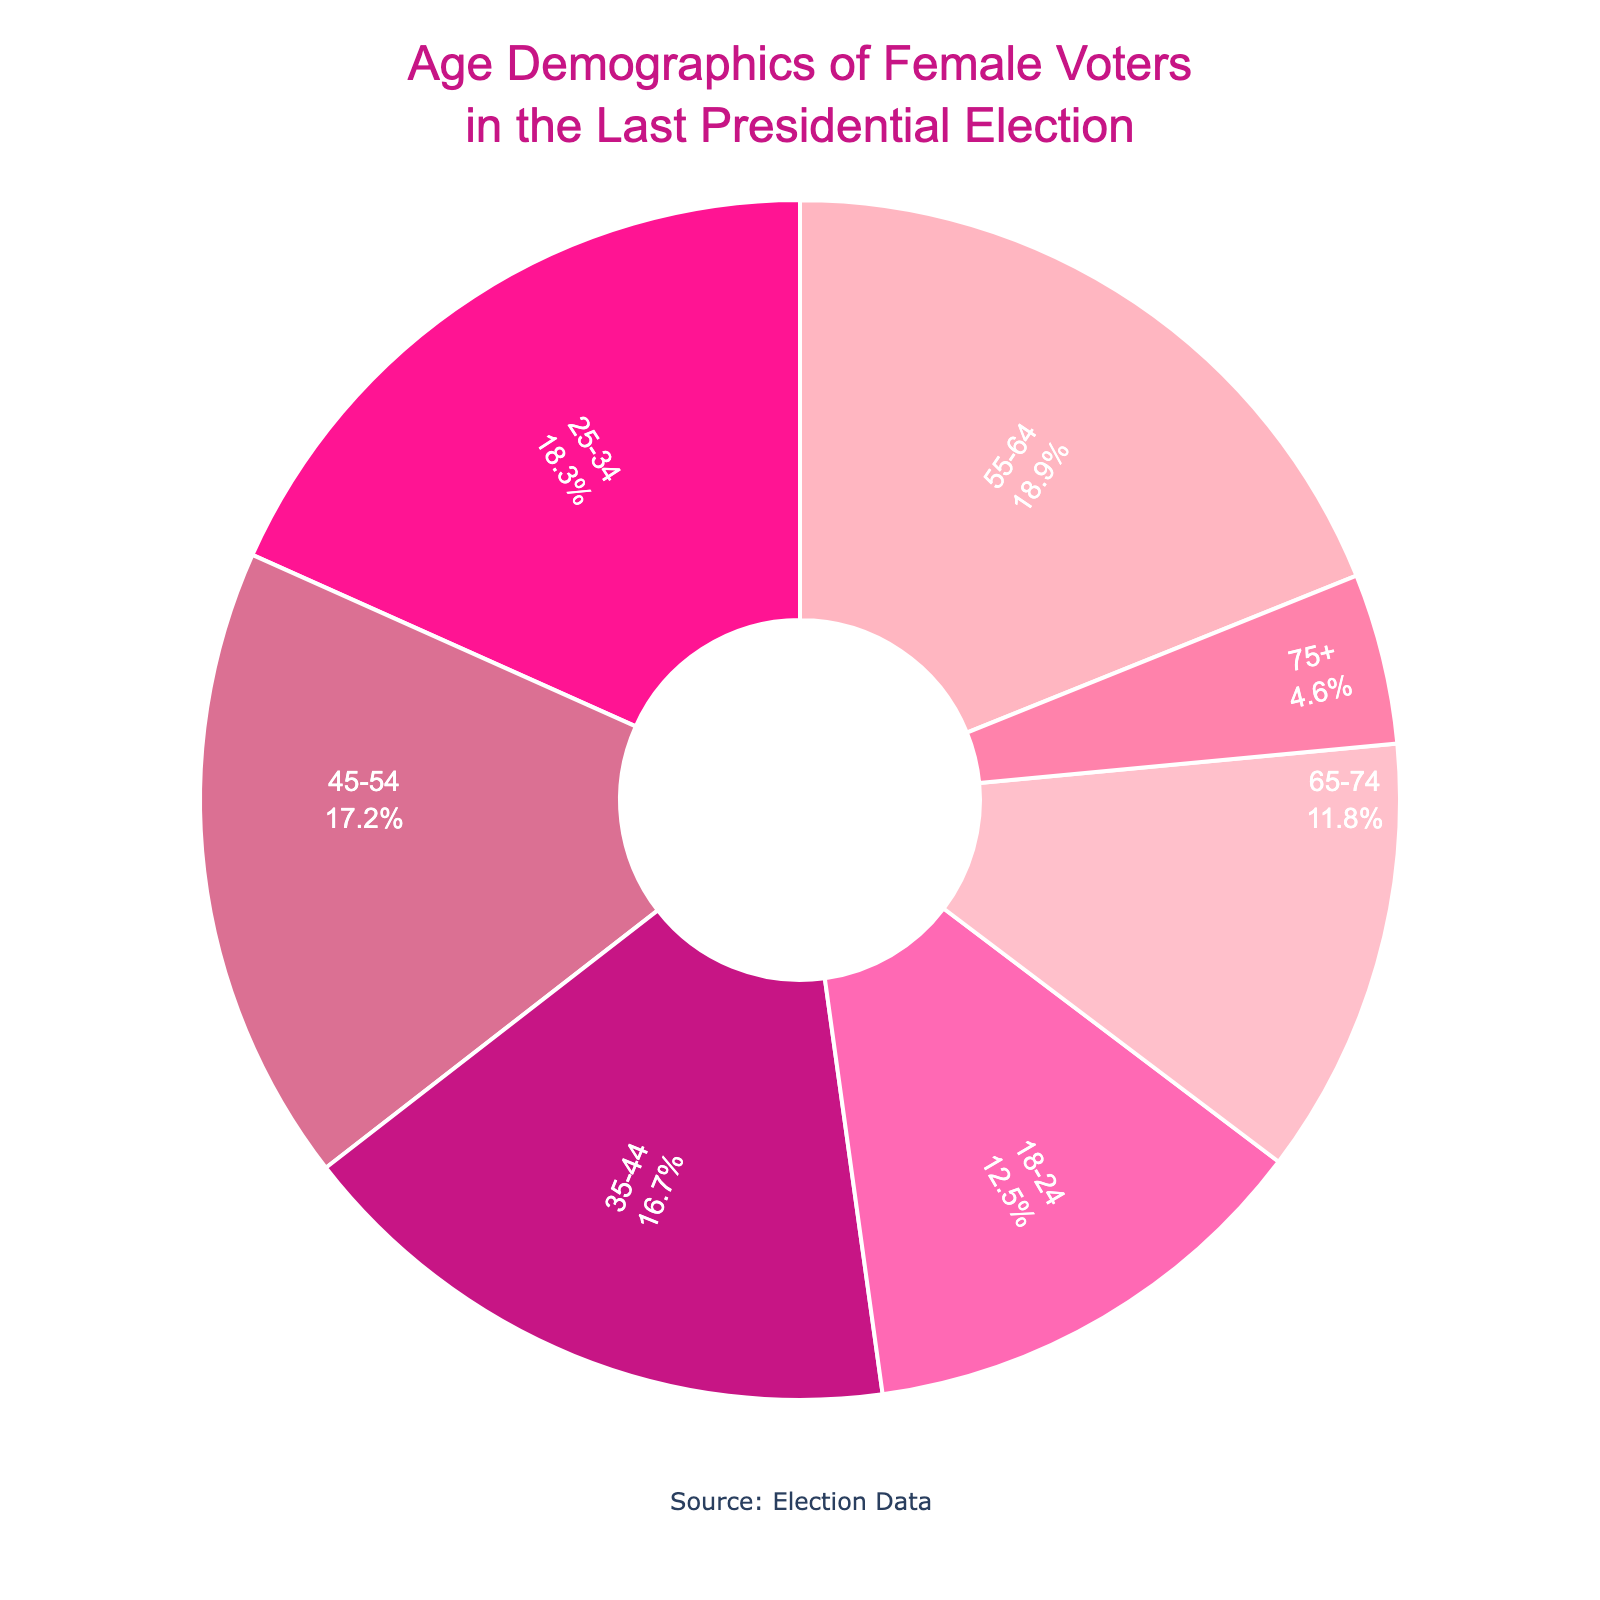What percentage of female voters are aged 25-34? The pie chart shows the distribution of age groups among female voters. By reading the label for the age group 25-34, we can see the percentage.
Answer: 18.3% Which age group has the smallest percentage of female voters? To find this, we visually inspect the slices of the pie chart and identify which one is the smallest. The label for the 75+ age group shows that it is the smallest with 4.6%.
Answer: 75+ How much larger is the percentage of female voters aged 55-64 compared to those aged 75+? We subtract the percentage of the 75+ group (4.6%) from the percentage of the 55-64 group (18.9%). So, 18.9% - 4.6% = 14.3%.
Answer: 14.3% What is the total percentage of female voters in the age groups 35-44 and 45-54 combined? We add the percentages for the 35-44 age group (16.7%) and the 45-54 age group (17.2%). So, 16.7% + 17.2% = 33.9%.
Answer: 33.9% Which age group has a higher percentage of female voters, 18-24 or 65-74? By comparing the percentages on the pie chart, we see that the 18-24 group has 12.5% while the 65-74 group has 11.8%. Thus, the 18-24 group has a higher percentage.
Answer: 18-24 What is the difference in percentage between female voters aged 25-34 and those aged 45-54? We subtract the percentage of the 45-54 group (17.2%) from the 25-34 group (18.3%). So, 18.3% - 17.2% = 1.1%.
Answer: 1.1% How much higher is the percentage of female voters aged 55-64 compared to the average percentage of all age groups? First, calculate the average percentage: (12.5 + 18.3 + 16.7 + 17.2 + 18.9 + 11.8 + 4.6) / 7 = 14.2857%. Then, subtract this average from the 55-64 group's percentage: 18.9% - 14.2857% = 4.6143%.
Answer: 4.6% In the pie chart, which age group has a pink-colored slice and what is its percentage of female voters? The age group with the pink-colored slice represents the 25-34 age group, which has a percentage of 18.3%.
Answer: 25-34, 18.3% What is the combined percentage of female voters aged 18-24, 25-34, and 65-74? Add the percentages of the 18-24 (12.5%), 25-34 (18.3%), and 65-74 (11.8%) groups: 12.5% + 18.3% + 11.8% = 42.6%.
Answer: 42.6% Which age group has nearly the same percentage of female voters as the 35-44 group, and what is their percentage? We compare the percentages visually and identify that the 45-54 age group (17.2%) has a percentage close to the 35-44 age group (16.7%).
Answer: 45-54, 17.2% 